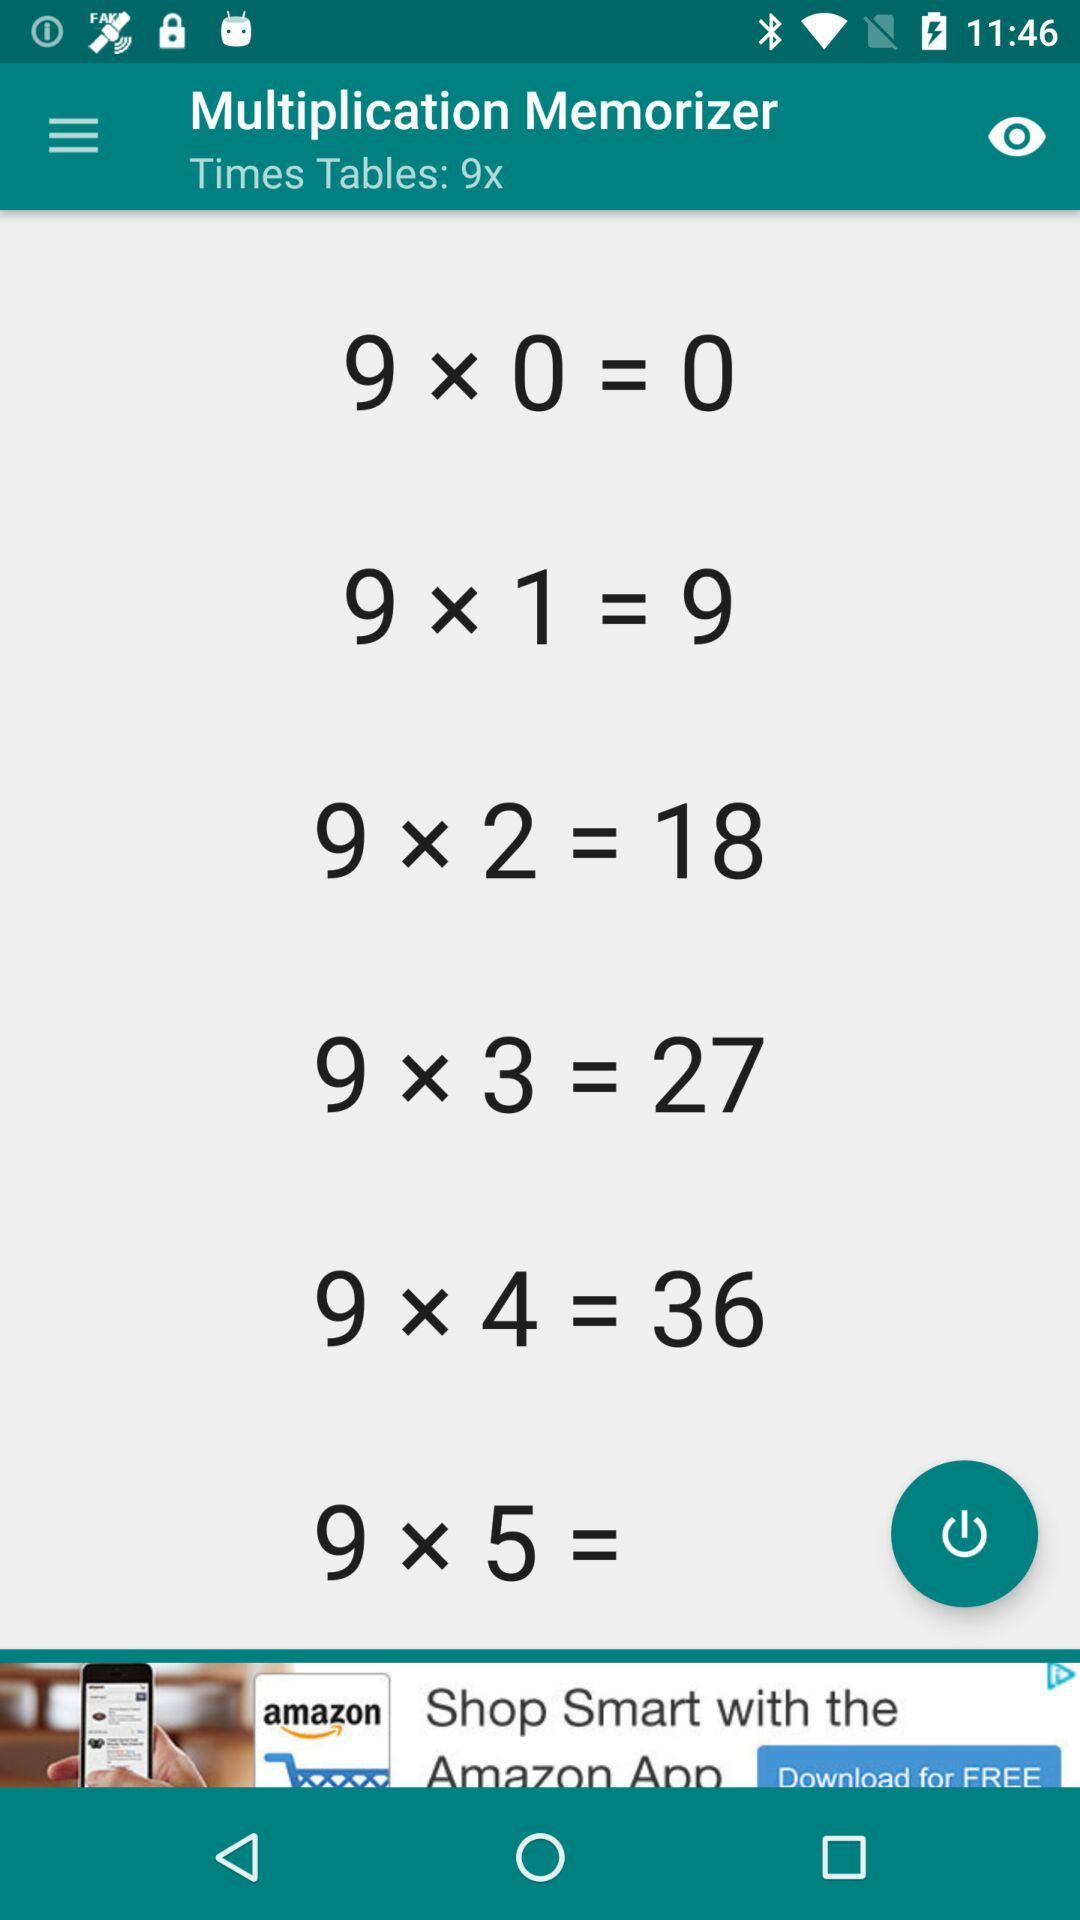What is the name of the application? The name of the application is "Multiplication Memorizer". 